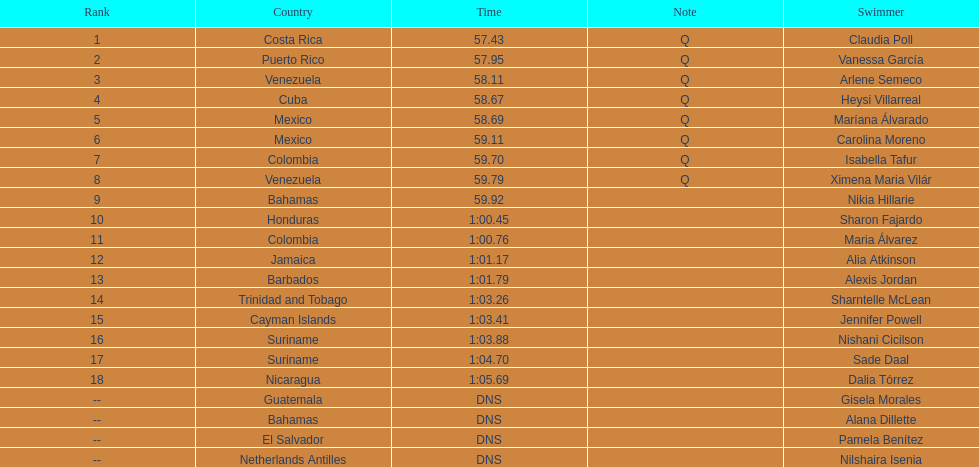Parse the full table. {'header': ['Rank', 'Country', 'Time', 'Note', 'Swimmer'], 'rows': [['1', 'Costa Rica', '57.43', 'Q', 'Claudia Poll'], ['2', 'Puerto Rico', '57.95', 'Q', 'Vanessa García'], ['3', 'Venezuela', '58.11', 'Q', 'Arlene Semeco'], ['4', 'Cuba', '58.67', 'Q', 'Heysi Villarreal'], ['5', 'Mexico', '58.69', 'Q', 'Maríana Álvarado'], ['6', 'Mexico', '59.11', 'Q', 'Carolina Moreno'], ['7', 'Colombia', '59.70', 'Q', 'Isabella Tafur'], ['8', 'Venezuela', '59.79', 'Q', 'Ximena Maria Vilár'], ['9', 'Bahamas', '59.92', '', 'Nikia Hillarie'], ['10', 'Honduras', '1:00.45', '', 'Sharon Fajardo'], ['11', 'Colombia', '1:00.76', '', 'Maria Álvarez'], ['12', 'Jamaica', '1:01.17', '', 'Alia Atkinson'], ['13', 'Barbados', '1:01.79', '', 'Alexis Jordan'], ['14', 'Trinidad and Tobago', '1:03.26', '', 'Sharntelle McLean'], ['15', 'Cayman Islands', '1:03.41', '', 'Jennifer Powell'], ['16', 'Suriname', '1:03.88', '', 'Nishani Cicilson'], ['17', 'Suriname', '1:04.70', '', 'Sade Daal'], ['18', 'Nicaragua', '1:05.69', '', 'Dalia Tórrez'], ['--', 'Guatemala', 'DNS', '', 'Gisela Morales'], ['--', 'Bahamas', 'DNS', '', 'Alana Dillette'], ['--', 'El Salvador', 'DNS', '', 'Pamela Benítez'], ['--', 'Netherlands Antilles', 'DNS', '', 'Nilshaira Isenia']]} How many mexican swimmers ranked in the top 10? 2. 